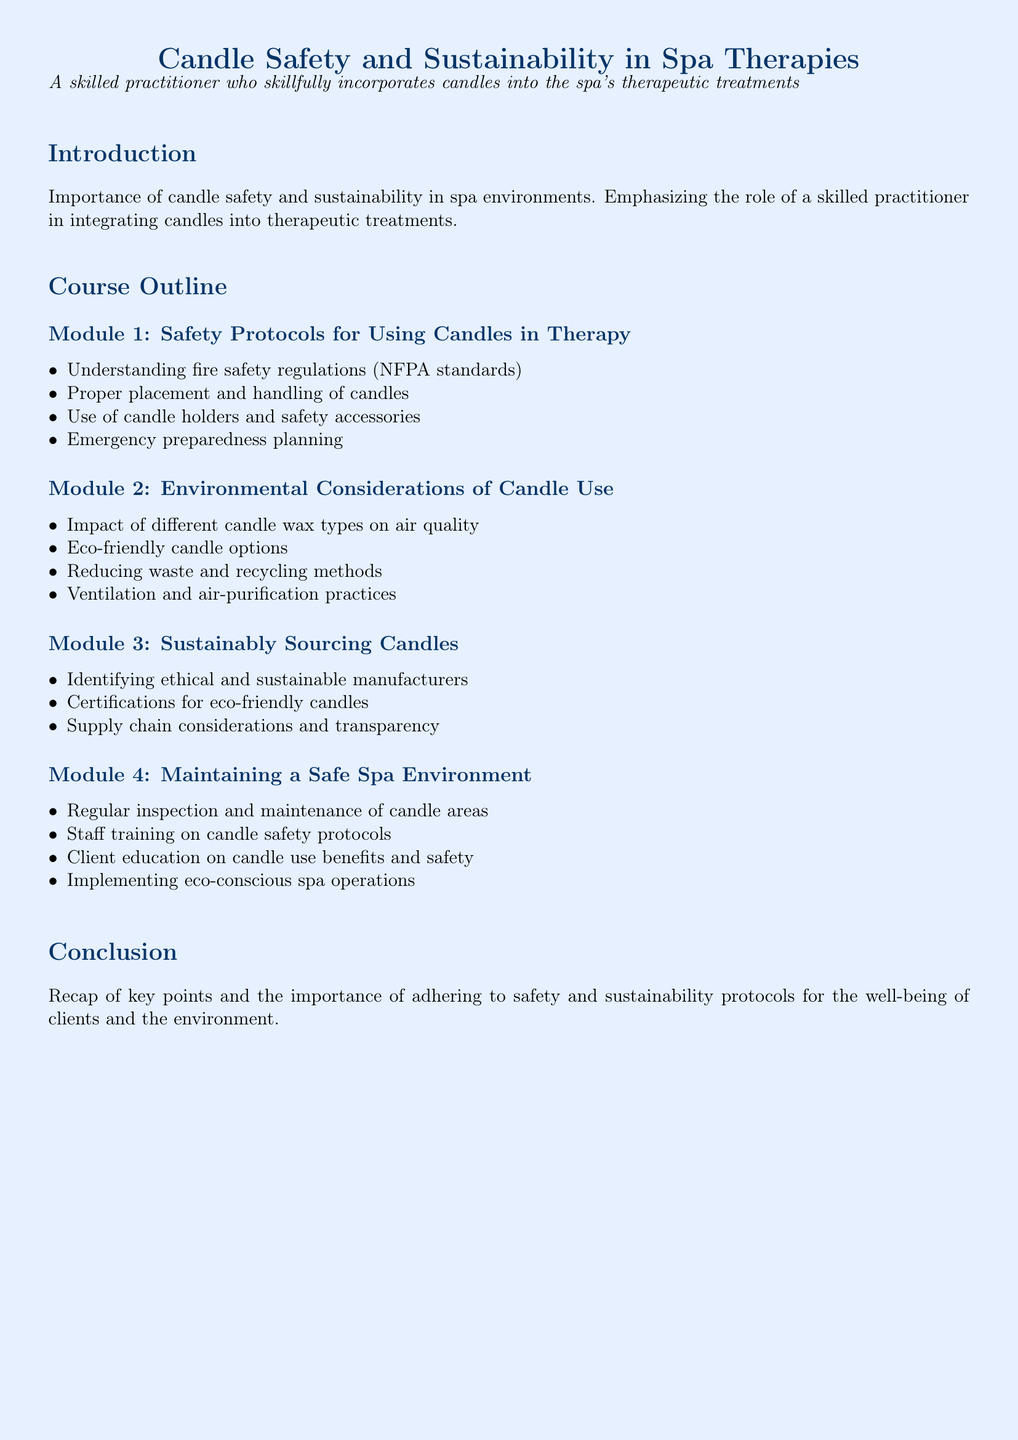what is the title of the syllabus? The title is prominently displayed at the top of the document, indicating the main focus of the material.
Answer: Candle Safety and Sustainability in Spa Therapies what is the first module about? The first module covers critical safety measures related to candle use, as detailed in the course outline.
Answer: Safety Protocols for Using Candles in Therapy how many modules are in the course outline? The number of modules is determined by counting the subsections listed in the course outline section.
Answer: Four what are eco-friendly options mentioned in module 2? The document specifically addresses environmentally friendly alternatives relevant to candle use.
Answer: Eco-friendly candle options which organization’s standards are referenced for fire safety regulations? The document cites a specific organization known for establishing fire safety regulations applicable in various settings.
Answer: NFPA what is an important practice mentioned in module 4 for maintaining a safe spa environment? The document highlights essential actions to ensure the safety of clients and staff in a spa setting.
Answer: Regular inspection and maintenance of candle areas what is a key aspect of module 3? The third module focuses on sourcing practices that align with ethical and environmental considerations.
Answer: Sustainably Sourcing Candles what is emphasized in the conclusion of the syllabus? The conclusion reviews the main themes discussed in the syllabus, reinforcing the overall importance of specific best practices.
Answer: Importance of adhering to safety and sustainability protocols 